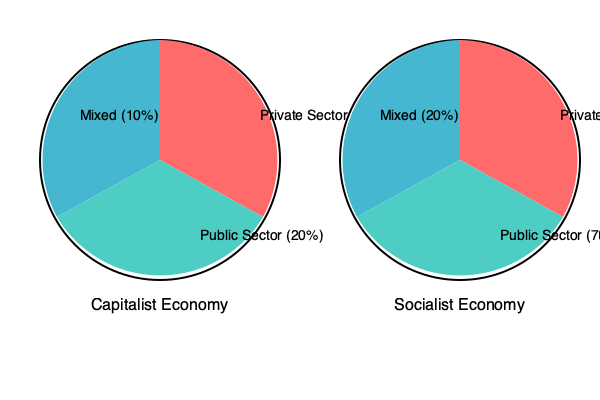Analyze the pie charts representing the distribution of economic control in capitalist and socialist economies. What key difference can you identify between these two systems, and how might this impact the role of government in each economy? To answer this question, let's break down the information presented in the pie charts and analyze the key differences:

1. Capitalist Economy:
   - Private Sector: 70%
   - Public Sector: 20%
   - Mixed: 10%

2. Socialist Economy:
   - Private Sector: 10%
   - Public Sector: 70%
   - Mixed: 20%

Key differences:
1. Dominant sector:
   - In the capitalist economy, the private sector dominates with 70% control.
   - In the socialist economy, the public sector dominates with 70% control.

2. Role reversal:
   - The percentages for private and public sectors are almost exactly reversed between the two systems.

3. Mixed sector:
   - The socialist economy has a slightly larger mixed sector (20%) compared to the capitalist economy (10%).

Impact on the role of government:

1. Capitalist Economy:
   - Limited government intervention
   - Focus on regulation and maintaining fair competition
   - Emphasis on individual economic freedom

2. Socialist Economy:
   - Extensive government involvement in economic planning and decision-making
   - Greater control over resource allocation and production
   - Focus on collective ownership and equal distribution of resources

The key difference is the level of government involvement in economic activities. In a capitalist system, the government's role is more limited, primarily focused on creating and enforcing regulations to ensure fair competition. In a socialist system, the government plays a central role in economic planning, resource allocation, and production decisions.
Answer: The key difference is the dominant economic sector: private (70%) in capitalism vs. public (70%) in socialism, resulting in limited government intervention in capitalism and extensive government involvement in socialism. 